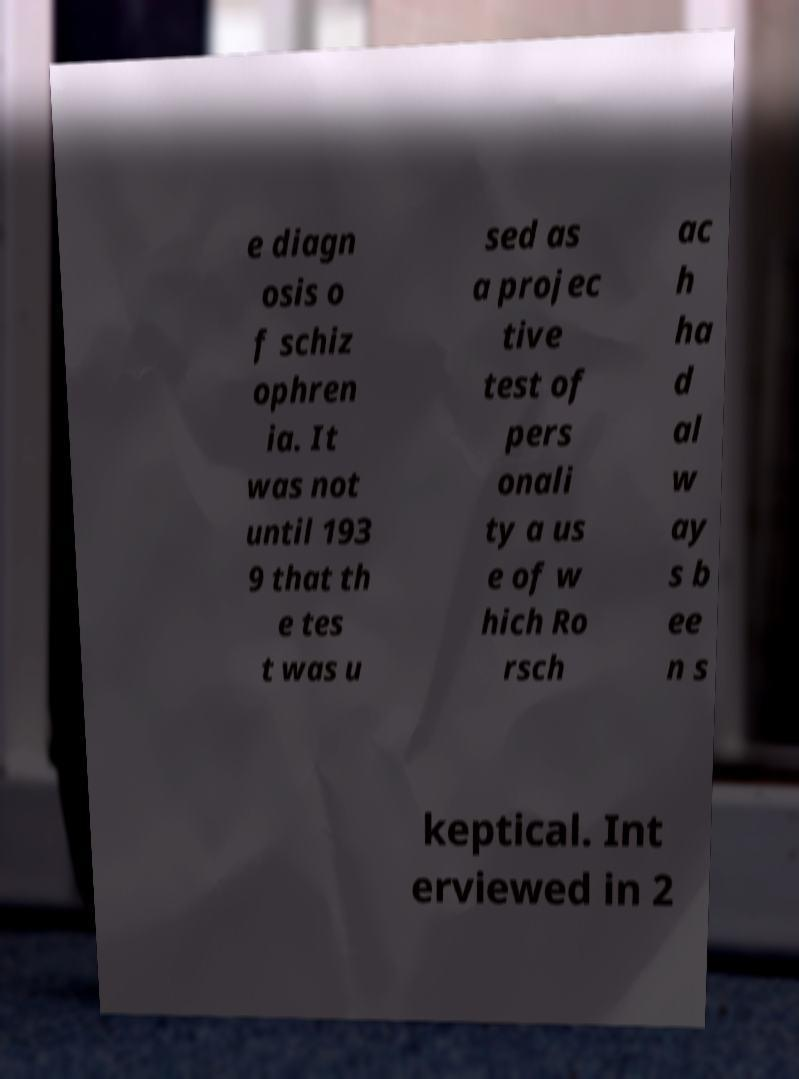I need the written content from this picture converted into text. Can you do that? e diagn osis o f schiz ophren ia. It was not until 193 9 that th e tes t was u sed as a projec tive test of pers onali ty a us e of w hich Ro rsch ac h ha d al w ay s b ee n s keptical. Int erviewed in 2 